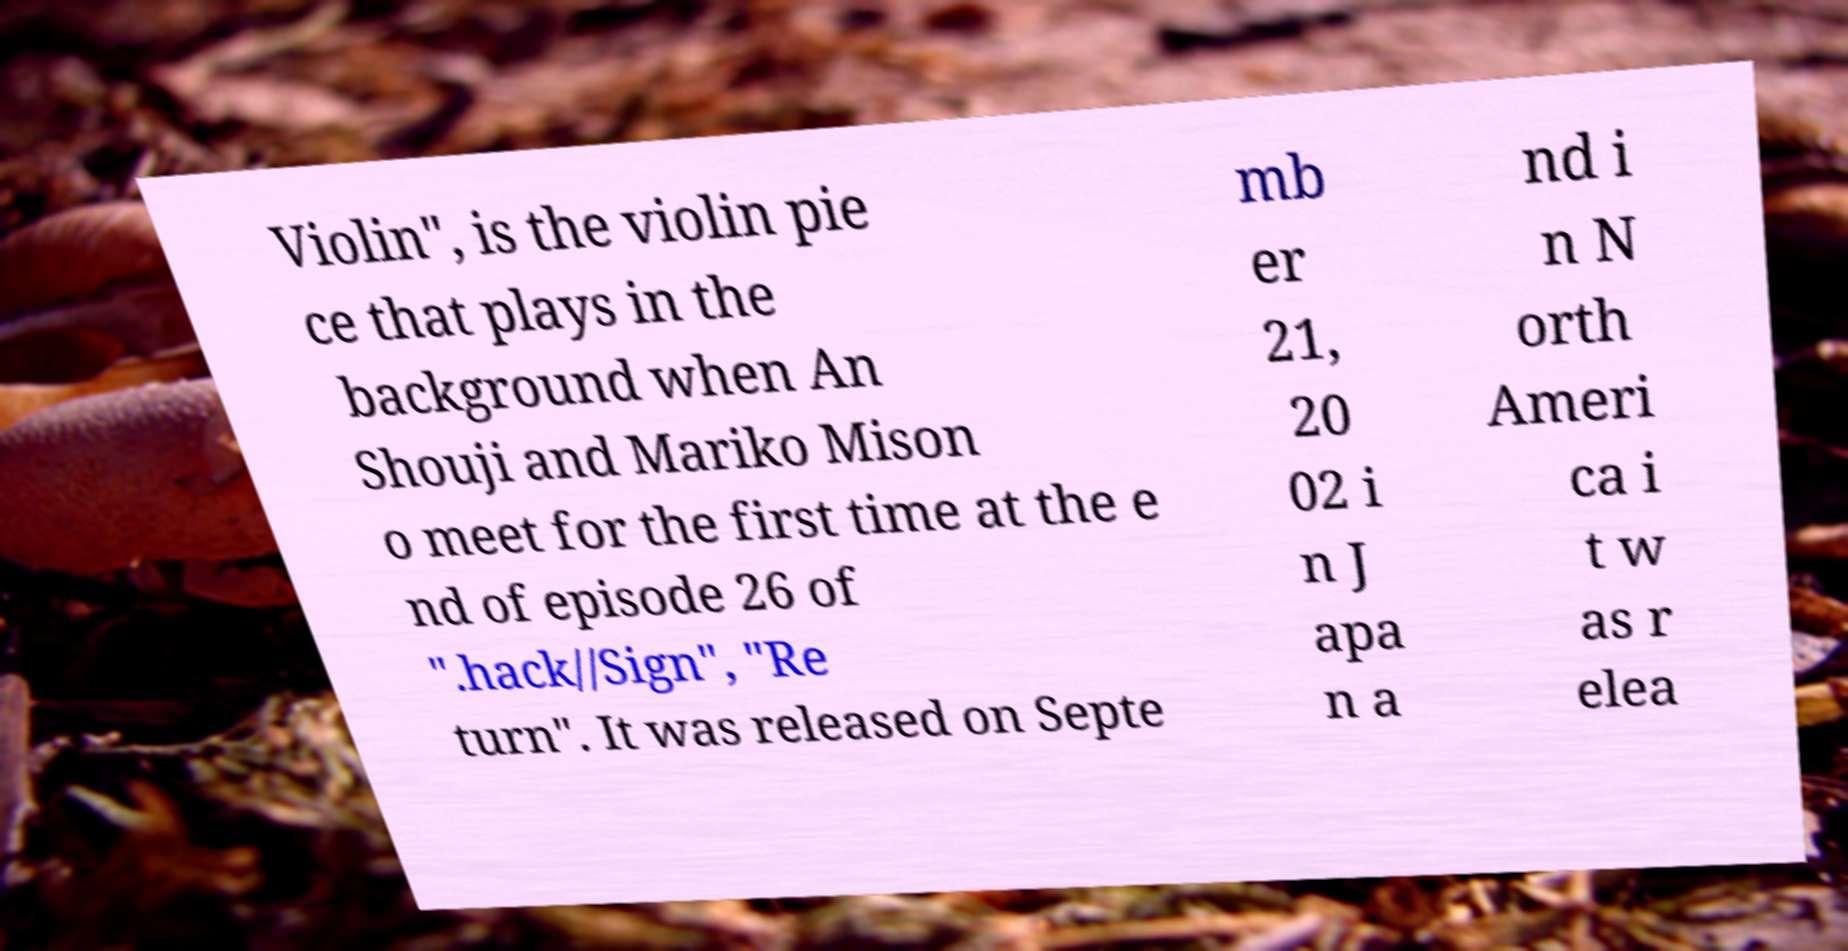Could you assist in decoding the text presented in this image and type it out clearly? Violin", is the violin pie ce that plays in the background when An Shouji and Mariko Mison o meet for the first time at the e nd of episode 26 of ".hack//Sign", "Re turn". It was released on Septe mb er 21, 20 02 i n J apa n a nd i n N orth Ameri ca i t w as r elea 